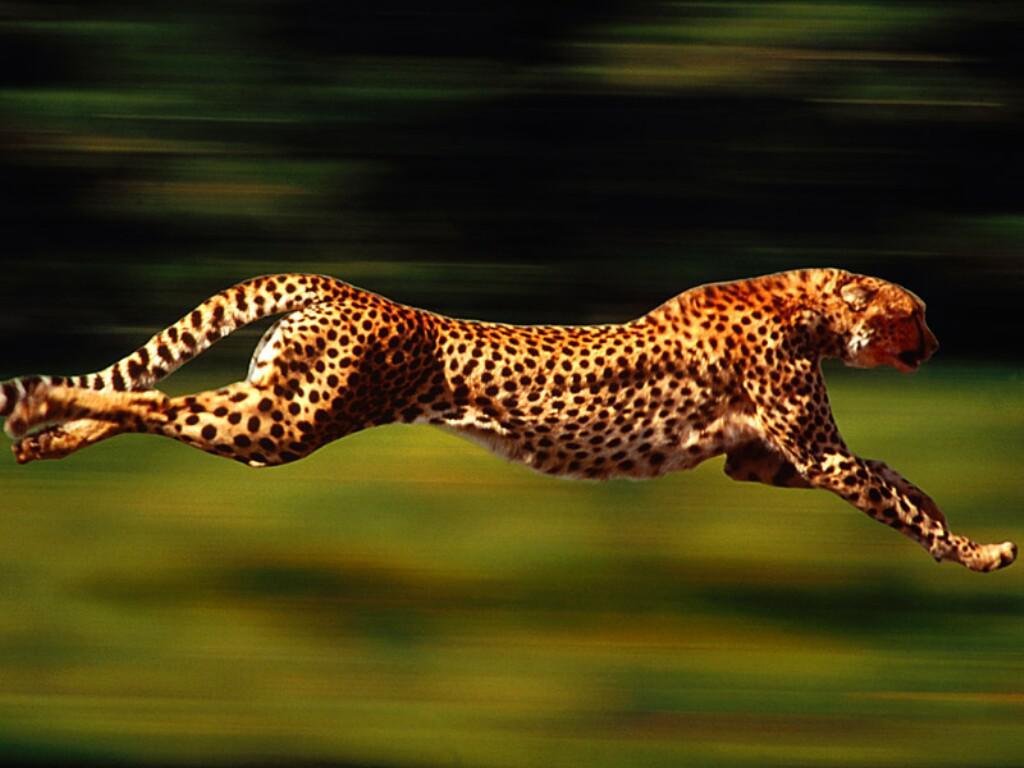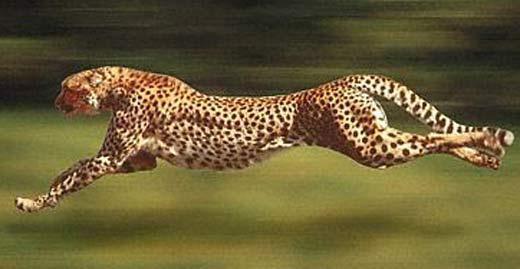The first image is the image on the left, the second image is the image on the right. Evaluate the accuracy of this statement regarding the images: "All the cheetahs are running the same direction, to the right.". Is it true? Answer yes or no. No. 